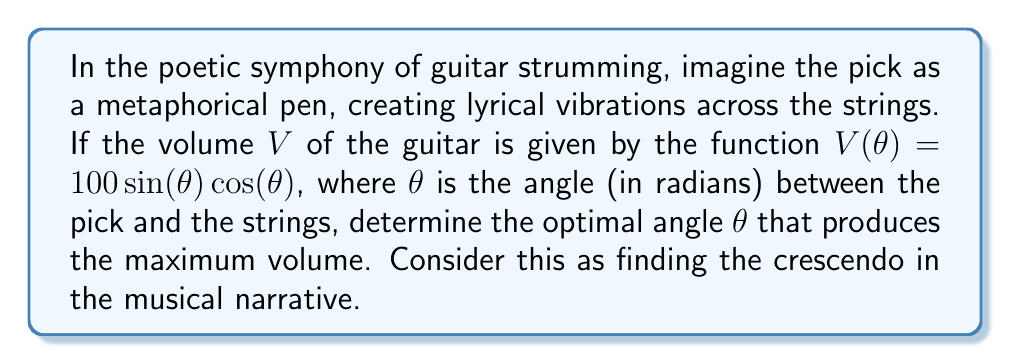Teach me how to tackle this problem. To find the optimal angle for maximum volume, we need to find the maximum of the function $V(\theta) = 100 \sin(\theta) \cos(\theta)$. This process is akin to finding the climax in a literary work.

1) First, let's recognize that $\sin(\theta) \cos(\theta) = \frac{1}{2} \sin(2\theta)$. This trigonometric identity allows us to rewrite our function as:

   $V(\theta) = 50 \sin(2\theta)$

2) To find the maximum, we need to find where the derivative of $V(\theta)$ equals zero. Let's differentiate:

   $\frac{dV}{d\theta} = 50 \cdot 2 \cos(2\theta) = 100 \cos(2\theta)$

3) Set this equal to zero and solve:

   $100 \cos(2\theta) = 0$
   $\cos(2\theta) = 0$

4) The cosine function equals zero when its argument is $\frac{\pi}{2}$ or $\frac{3\pi}{2}$. So:

   $2\theta = \frac{\pi}{2}$ or $2\theta = \frac{3\pi}{2}$
   $\theta = \frac{\pi}{4}$ or $\theta = \frac{3\pi}{4}$

5) To determine which of these gives the maximum (rather than minimum), we can check the second derivative:

   $\frac{d^2V}{d\theta^2} = -200 \sin(2\theta)$

   At $\theta = \frac{\pi}{4}$, this is negative, indicating a maximum.

6) We can confirm this by evaluating $V(\theta)$ at both points:

   $V(\frac{\pi}{4}) = 50 \sin(\frac{\pi}{2}) = 50$
   $V(\frac{3\pi}{4}) = 50 \sin(\frac{3\pi}{2}) = -50$

Therefore, the maximum occurs at $\theta = \frac{\pi}{4}$ radians, or 45 degrees.
Answer: The optimal angle for strumming the guitar to maximize volume is $\frac{\pi}{4}$ radians or 45 degrees. 